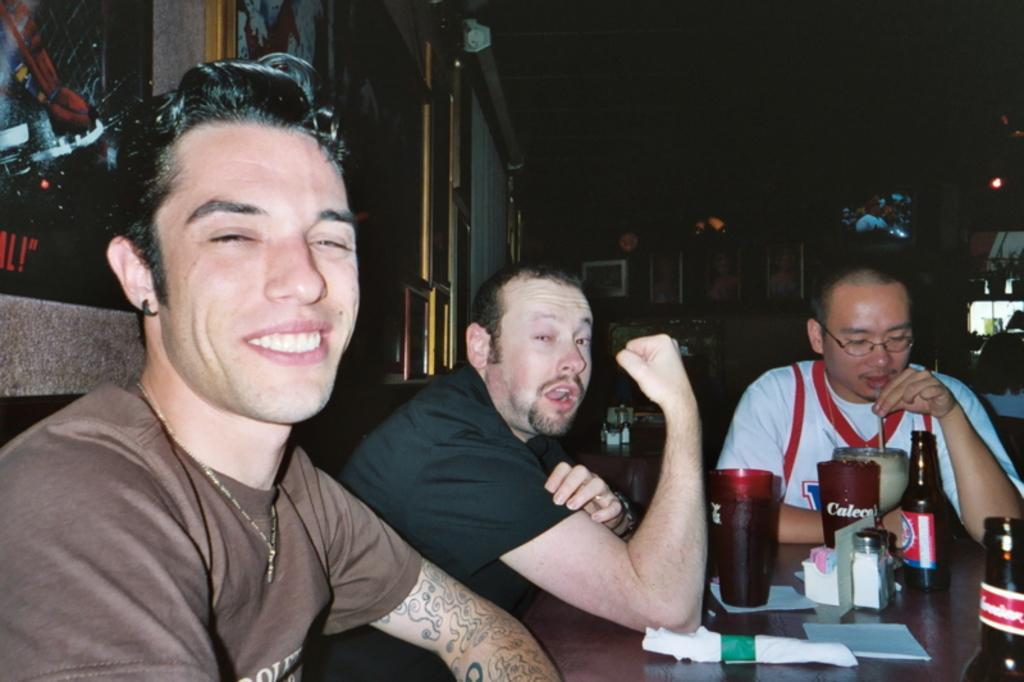Please provide a concise description of this image. In this picture we can see people, in front of them we can see a platform, on this platform we can see bottles, glasses, tissue papers and some objects and in the background we can see photo frames, screen and some objects 